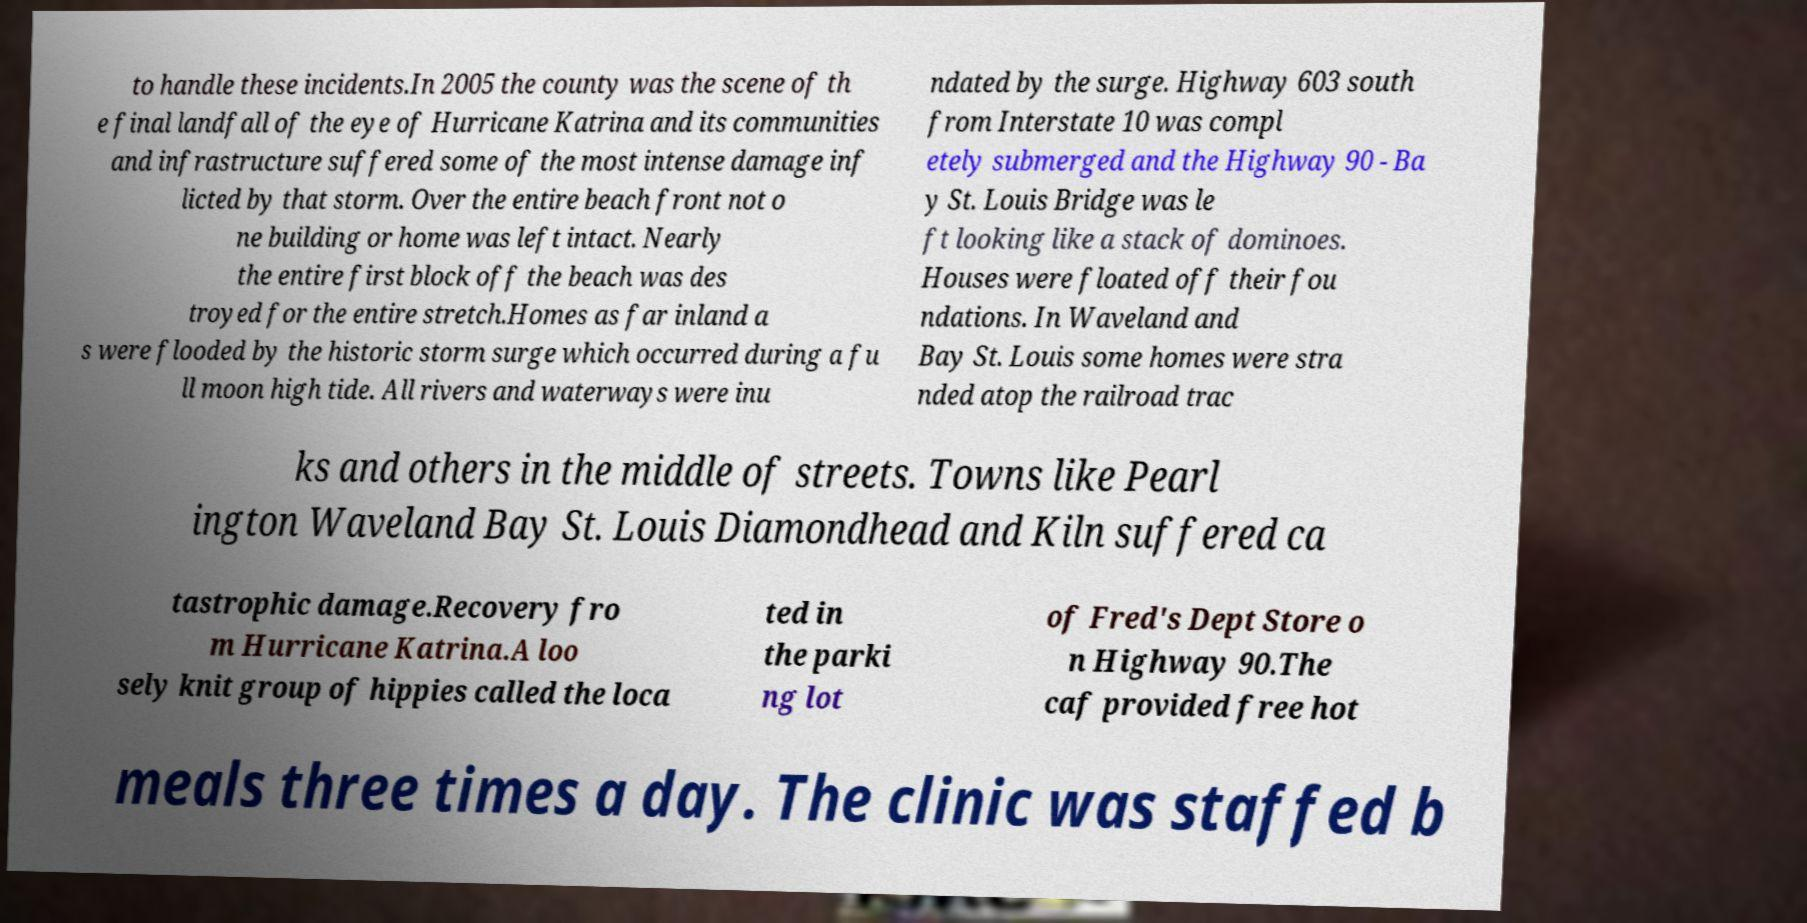Can you accurately transcribe the text from the provided image for me? to handle these incidents.In 2005 the county was the scene of th e final landfall of the eye of Hurricane Katrina and its communities and infrastructure suffered some of the most intense damage inf licted by that storm. Over the entire beach front not o ne building or home was left intact. Nearly the entire first block off the beach was des troyed for the entire stretch.Homes as far inland a s were flooded by the historic storm surge which occurred during a fu ll moon high tide. All rivers and waterways were inu ndated by the surge. Highway 603 south from Interstate 10 was compl etely submerged and the Highway 90 - Ba y St. Louis Bridge was le ft looking like a stack of dominoes. Houses were floated off their fou ndations. In Waveland and Bay St. Louis some homes were stra nded atop the railroad trac ks and others in the middle of streets. Towns like Pearl ington Waveland Bay St. Louis Diamondhead and Kiln suffered ca tastrophic damage.Recovery fro m Hurricane Katrina.A loo sely knit group of hippies called the loca ted in the parki ng lot of Fred's Dept Store o n Highway 90.The caf provided free hot meals three times a day. The clinic was staffed b 